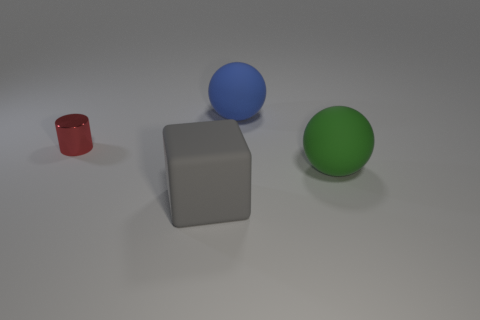Subtract all cubes. How many objects are left? 3 Subtract 1 spheres. How many spheres are left? 1 Subtract all purple cylinders. Subtract all blue balls. How many cylinders are left? 1 Subtract all brown blocks. How many purple cylinders are left? 0 Subtract all large gray rubber spheres. Subtract all big balls. How many objects are left? 2 Add 4 blue balls. How many blue balls are left? 5 Add 4 large cylinders. How many large cylinders exist? 4 Add 4 small brown rubber balls. How many objects exist? 8 Subtract all green balls. How many balls are left? 1 Subtract 0 cyan cubes. How many objects are left? 4 